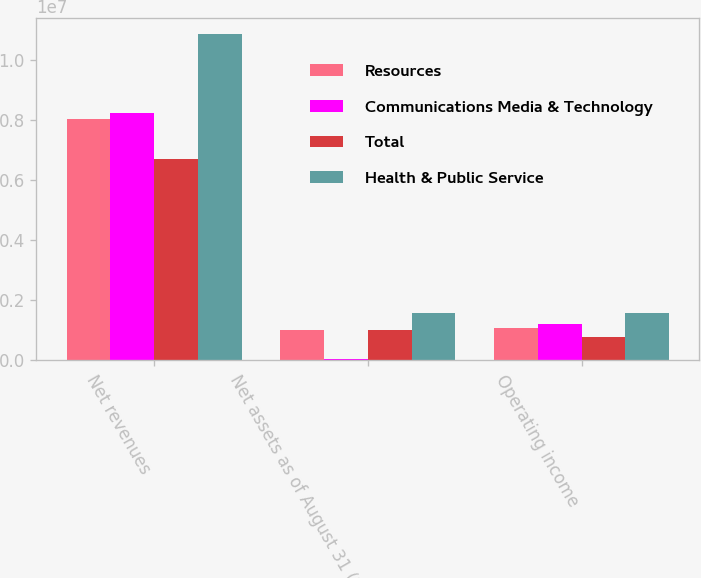<chart> <loc_0><loc_0><loc_500><loc_500><stacked_bar_chart><ecel><fcel>Net revenues<fcel>Net assets as of August 31 (2)<fcel>Operating income<nl><fcel>Resources<fcel>8.03078e+06<fcel>984345<fcel>1.04879e+06<nl><fcel>Communications Media & Technology<fcel>8.23798e+06<fcel>23666<fcel>1.20739e+06<nl><fcel>Total<fcel>6.68847e+06<fcel>989150<fcel>772785<nl><fcel>Health & Public Service<fcel>1.08543e+07<fcel>1.57162e+06<fcel>1.55868e+06<nl></chart> 